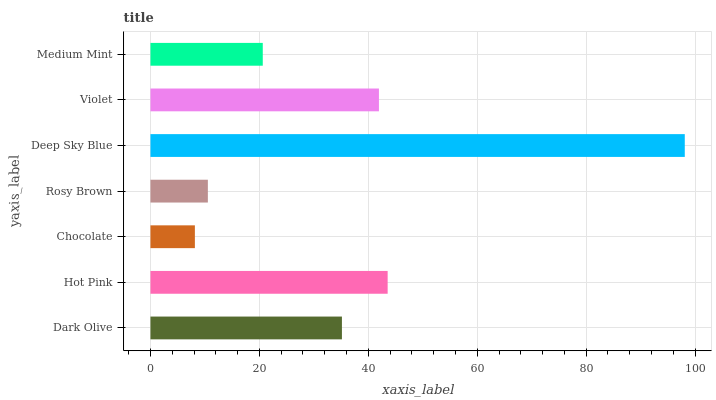Is Chocolate the minimum?
Answer yes or no. Yes. Is Deep Sky Blue the maximum?
Answer yes or no. Yes. Is Hot Pink the minimum?
Answer yes or no. No. Is Hot Pink the maximum?
Answer yes or no. No. Is Hot Pink greater than Dark Olive?
Answer yes or no. Yes. Is Dark Olive less than Hot Pink?
Answer yes or no. Yes. Is Dark Olive greater than Hot Pink?
Answer yes or no. No. Is Hot Pink less than Dark Olive?
Answer yes or no. No. Is Dark Olive the high median?
Answer yes or no. Yes. Is Dark Olive the low median?
Answer yes or no. Yes. Is Violet the high median?
Answer yes or no. No. Is Deep Sky Blue the low median?
Answer yes or no. No. 